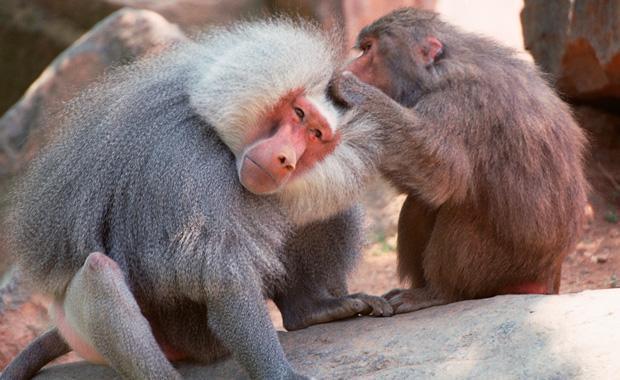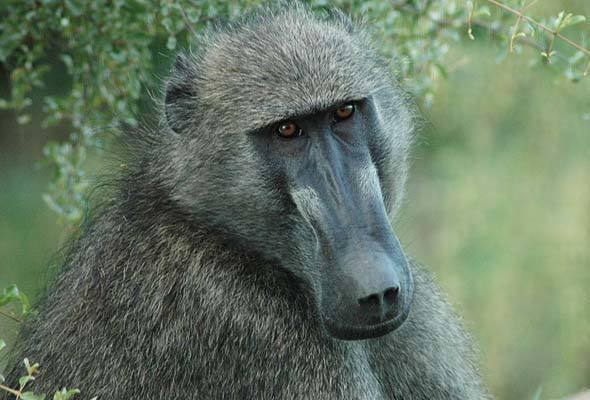The first image is the image on the left, the second image is the image on the right. Assess this claim about the two images: "Teeth are visible in the baboons in each image.". Correct or not? Answer yes or no. No. 